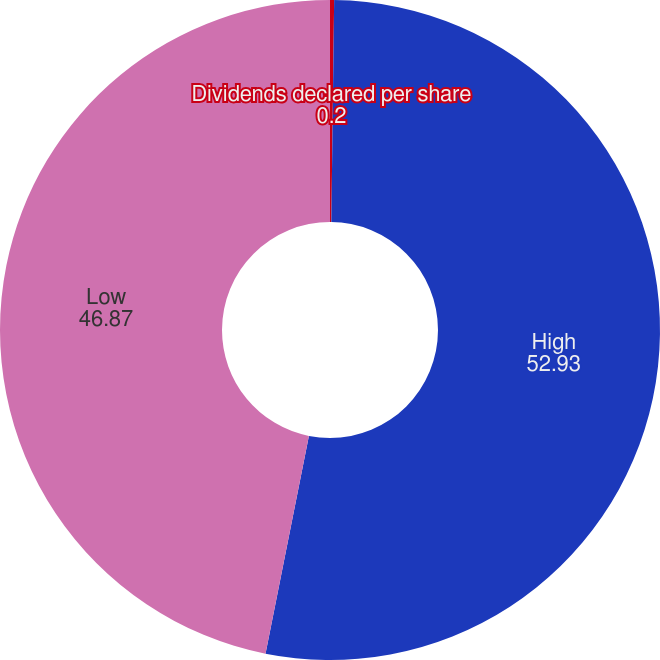Convert chart. <chart><loc_0><loc_0><loc_500><loc_500><pie_chart><fcel>Dividends declared per share<fcel>High<fcel>Low<nl><fcel>0.2%<fcel>52.93%<fcel>46.87%<nl></chart> 